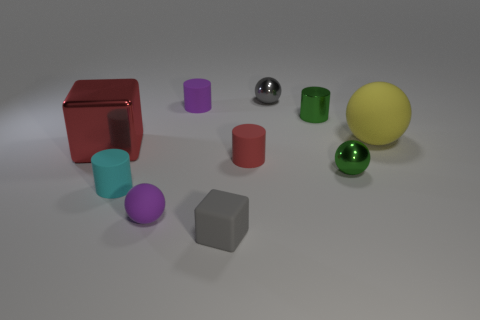Subtract all blue blocks. Subtract all blue balls. How many blocks are left? 2 Subtract all blue blocks. How many gray spheres are left? 1 Add 4 greens. How many large objects exist? 0 Subtract all small things. Subtract all tiny red metal cylinders. How many objects are left? 2 Add 1 purple matte balls. How many purple matte balls are left? 2 Add 10 red rubber blocks. How many red rubber blocks exist? 10 Subtract all green spheres. How many spheres are left? 3 Subtract all shiny cylinders. How many cylinders are left? 3 Subtract 0 brown cubes. How many objects are left? 10 Subtract all cubes. How many objects are left? 8 